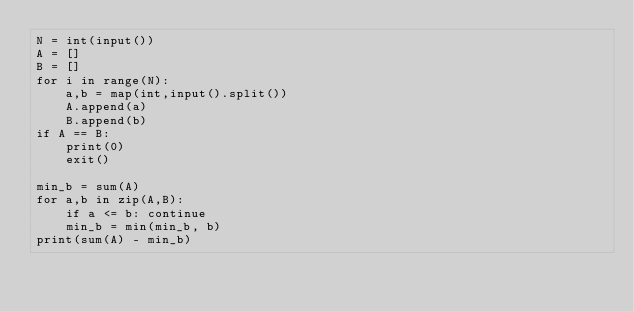<code> <loc_0><loc_0><loc_500><loc_500><_Python_>N = int(input())
A = []
B = []
for i in range(N):
    a,b = map(int,input().split())
    A.append(a)
    B.append(b)
if A == B:
    print(0)
    exit()

min_b = sum(A)
for a,b in zip(A,B):
    if a <= b: continue
    min_b = min(min_b, b)
print(sum(A) - min_b)
</code> 